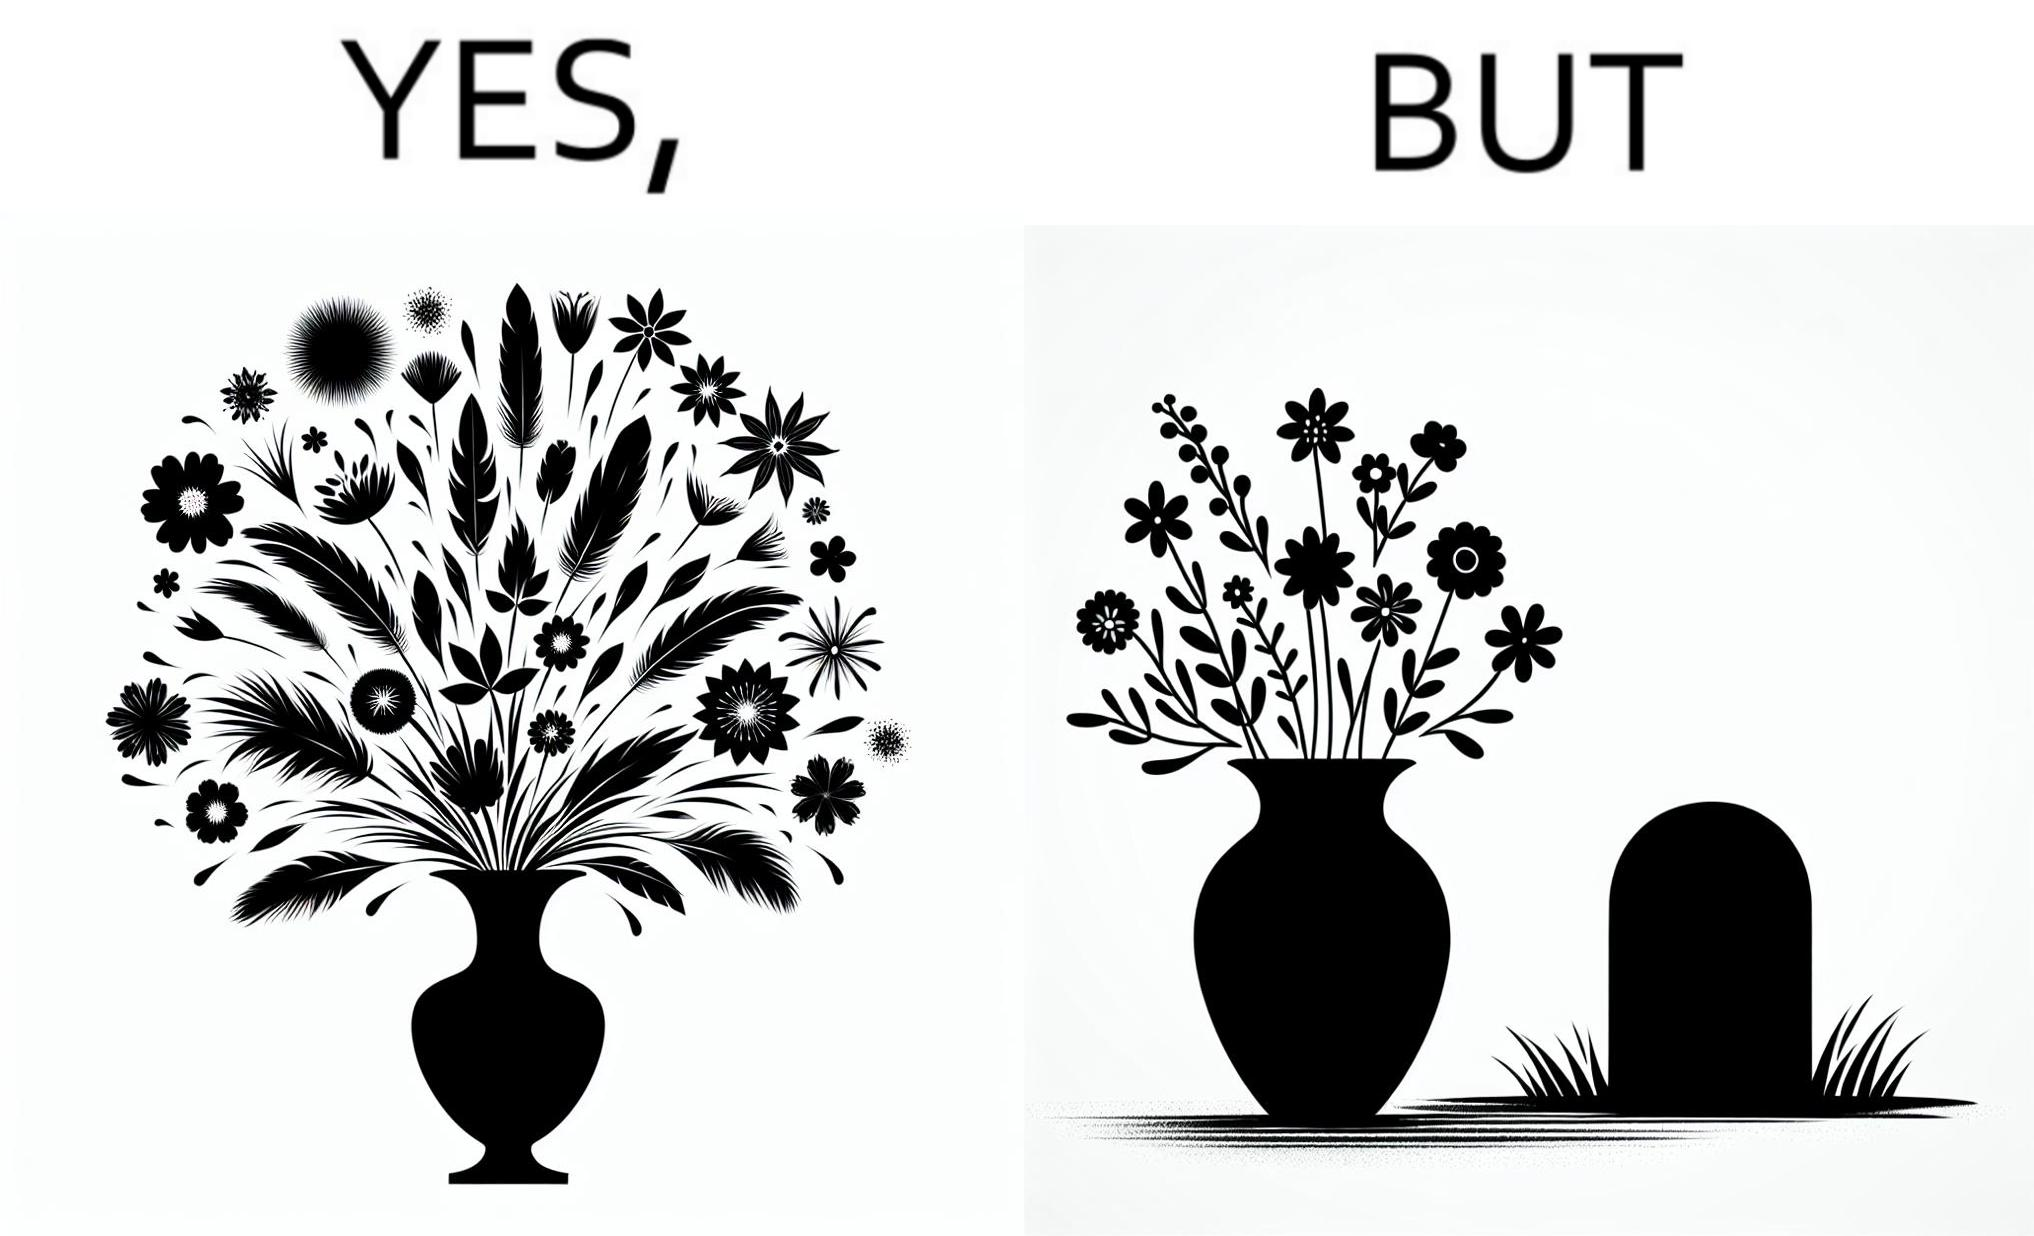Is this a satirical image? Yes, this image is satirical. 